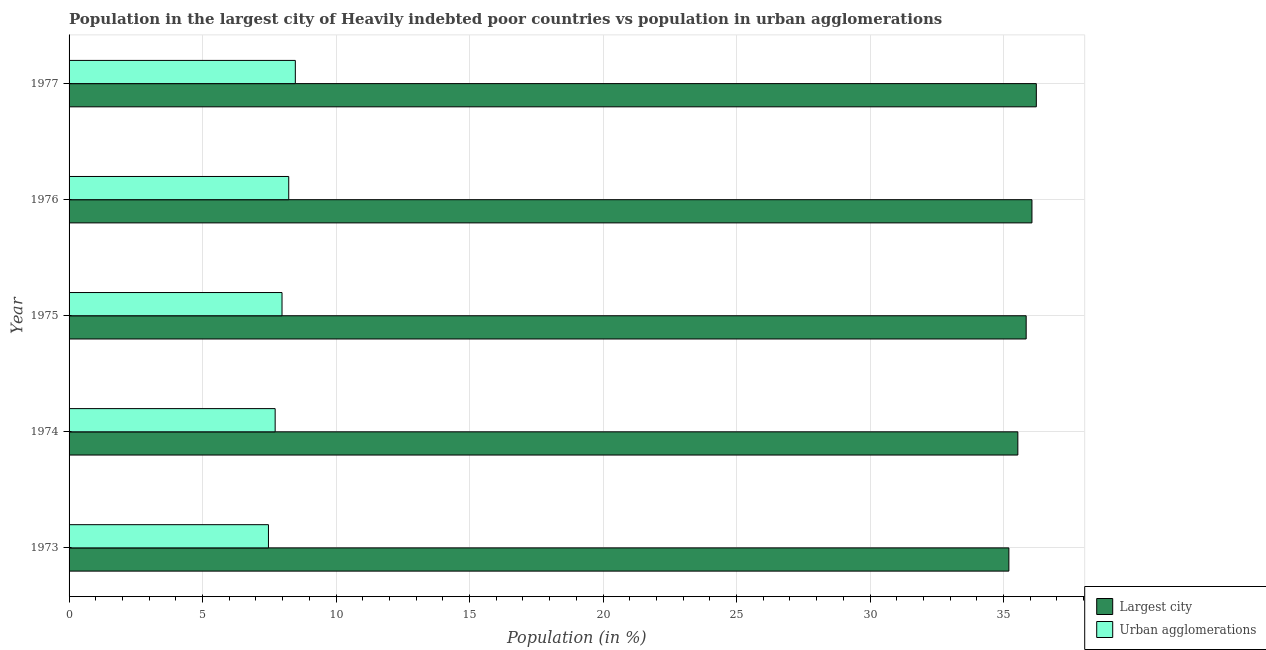How many groups of bars are there?
Your answer should be compact. 5. Are the number of bars per tick equal to the number of legend labels?
Your response must be concise. Yes. How many bars are there on the 3rd tick from the top?
Your answer should be compact. 2. In how many cases, is the number of bars for a given year not equal to the number of legend labels?
Make the answer very short. 0. What is the population in urban agglomerations in 1974?
Give a very brief answer. 7.72. Across all years, what is the maximum population in the largest city?
Offer a terse response. 36.23. Across all years, what is the minimum population in the largest city?
Provide a short and direct response. 35.2. In which year was the population in urban agglomerations maximum?
Make the answer very short. 1977. In which year was the population in urban agglomerations minimum?
Keep it short and to the point. 1973. What is the total population in urban agglomerations in the graph?
Your answer should be very brief. 39.87. What is the difference between the population in the largest city in 1975 and that in 1977?
Your answer should be very brief. -0.38. What is the difference between the population in the largest city in 1976 and the population in urban agglomerations in 1974?
Your response must be concise. 28.35. What is the average population in urban agglomerations per year?
Provide a short and direct response. 7.97. In the year 1975, what is the difference between the population in urban agglomerations and population in the largest city?
Give a very brief answer. -27.87. In how many years, is the population in the largest city greater than 14 %?
Make the answer very short. 5. What is the difference between the highest and the second highest population in the largest city?
Provide a short and direct response. 0.16. What is the difference between the highest and the lowest population in the largest city?
Offer a terse response. 1.03. In how many years, is the population in urban agglomerations greater than the average population in urban agglomerations taken over all years?
Offer a terse response. 3. Is the sum of the population in the largest city in 1976 and 1977 greater than the maximum population in urban agglomerations across all years?
Keep it short and to the point. Yes. What does the 1st bar from the top in 1974 represents?
Offer a very short reply. Urban agglomerations. What does the 1st bar from the bottom in 1976 represents?
Provide a succinct answer. Largest city. Are all the bars in the graph horizontal?
Make the answer very short. Yes. How many years are there in the graph?
Give a very brief answer. 5. Are the values on the major ticks of X-axis written in scientific E-notation?
Provide a succinct answer. No. Where does the legend appear in the graph?
Offer a terse response. Bottom right. How many legend labels are there?
Your response must be concise. 2. How are the legend labels stacked?
Offer a terse response. Vertical. What is the title of the graph?
Your answer should be very brief. Population in the largest city of Heavily indebted poor countries vs population in urban agglomerations. Does "Electricity and heat production" appear as one of the legend labels in the graph?
Make the answer very short. No. What is the Population (in %) of Largest city in 1973?
Provide a short and direct response. 35.2. What is the Population (in %) in Urban agglomerations in 1973?
Provide a short and direct response. 7.47. What is the Population (in %) in Largest city in 1974?
Offer a terse response. 35.54. What is the Population (in %) of Urban agglomerations in 1974?
Your response must be concise. 7.72. What is the Population (in %) in Largest city in 1975?
Provide a short and direct response. 35.85. What is the Population (in %) of Urban agglomerations in 1975?
Keep it short and to the point. 7.98. What is the Population (in %) in Largest city in 1976?
Make the answer very short. 36.07. What is the Population (in %) of Urban agglomerations in 1976?
Make the answer very short. 8.23. What is the Population (in %) of Largest city in 1977?
Give a very brief answer. 36.23. What is the Population (in %) of Urban agglomerations in 1977?
Your answer should be very brief. 8.47. Across all years, what is the maximum Population (in %) of Largest city?
Ensure brevity in your answer.  36.23. Across all years, what is the maximum Population (in %) of Urban agglomerations?
Keep it short and to the point. 8.47. Across all years, what is the minimum Population (in %) of Largest city?
Your response must be concise. 35.2. Across all years, what is the minimum Population (in %) of Urban agglomerations?
Give a very brief answer. 7.47. What is the total Population (in %) of Largest city in the graph?
Your answer should be very brief. 178.88. What is the total Population (in %) of Urban agglomerations in the graph?
Give a very brief answer. 39.87. What is the difference between the Population (in %) in Largest city in 1973 and that in 1974?
Give a very brief answer. -0.34. What is the difference between the Population (in %) in Urban agglomerations in 1973 and that in 1974?
Give a very brief answer. -0.25. What is the difference between the Population (in %) in Largest city in 1973 and that in 1975?
Ensure brevity in your answer.  -0.65. What is the difference between the Population (in %) in Urban agglomerations in 1973 and that in 1975?
Your answer should be compact. -0.51. What is the difference between the Population (in %) in Largest city in 1973 and that in 1976?
Ensure brevity in your answer.  -0.86. What is the difference between the Population (in %) in Urban agglomerations in 1973 and that in 1976?
Provide a succinct answer. -0.76. What is the difference between the Population (in %) of Largest city in 1973 and that in 1977?
Your answer should be very brief. -1.03. What is the difference between the Population (in %) in Urban agglomerations in 1973 and that in 1977?
Your answer should be compact. -1.01. What is the difference between the Population (in %) of Largest city in 1974 and that in 1975?
Give a very brief answer. -0.31. What is the difference between the Population (in %) in Urban agglomerations in 1974 and that in 1975?
Ensure brevity in your answer.  -0.26. What is the difference between the Population (in %) of Largest city in 1974 and that in 1976?
Your answer should be compact. -0.53. What is the difference between the Population (in %) of Urban agglomerations in 1974 and that in 1976?
Make the answer very short. -0.51. What is the difference between the Population (in %) of Largest city in 1974 and that in 1977?
Offer a terse response. -0.69. What is the difference between the Population (in %) of Urban agglomerations in 1974 and that in 1977?
Make the answer very short. -0.76. What is the difference between the Population (in %) of Largest city in 1975 and that in 1976?
Provide a short and direct response. -0.22. What is the difference between the Population (in %) in Urban agglomerations in 1975 and that in 1976?
Provide a succinct answer. -0.25. What is the difference between the Population (in %) in Largest city in 1975 and that in 1977?
Your answer should be very brief. -0.38. What is the difference between the Population (in %) in Urban agglomerations in 1975 and that in 1977?
Your answer should be compact. -0.5. What is the difference between the Population (in %) in Largest city in 1976 and that in 1977?
Your answer should be compact. -0.16. What is the difference between the Population (in %) of Urban agglomerations in 1976 and that in 1977?
Offer a very short reply. -0.25. What is the difference between the Population (in %) of Largest city in 1973 and the Population (in %) of Urban agglomerations in 1974?
Your response must be concise. 27.48. What is the difference between the Population (in %) of Largest city in 1973 and the Population (in %) of Urban agglomerations in 1975?
Provide a succinct answer. 27.23. What is the difference between the Population (in %) in Largest city in 1973 and the Population (in %) in Urban agglomerations in 1976?
Provide a short and direct response. 26.97. What is the difference between the Population (in %) of Largest city in 1973 and the Population (in %) of Urban agglomerations in 1977?
Offer a terse response. 26.73. What is the difference between the Population (in %) in Largest city in 1974 and the Population (in %) in Urban agglomerations in 1975?
Ensure brevity in your answer.  27.56. What is the difference between the Population (in %) in Largest city in 1974 and the Population (in %) in Urban agglomerations in 1976?
Make the answer very short. 27.31. What is the difference between the Population (in %) in Largest city in 1974 and the Population (in %) in Urban agglomerations in 1977?
Offer a terse response. 27.06. What is the difference between the Population (in %) in Largest city in 1975 and the Population (in %) in Urban agglomerations in 1976?
Your response must be concise. 27.62. What is the difference between the Population (in %) of Largest city in 1975 and the Population (in %) of Urban agglomerations in 1977?
Ensure brevity in your answer.  27.37. What is the difference between the Population (in %) of Largest city in 1976 and the Population (in %) of Urban agglomerations in 1977?
Give a very brief answer. 27.59. What is the average Population (in %) of Largest city per year?
Ensure brevity in your answer.  35.78. What is the average Population (in %) of Urban agglomerations per year?
Your answer should be very brief. 7.97. In the year 1973, what is the difference between the Population (in %) in Largest city and Population (in %) in Urban agglomerations?
Offer a very short reply. 27.73. In the year 1974, what is the difference between the Population (in %) in Largest city and Population (in %) in Urban agglomerations?
Offer a terse response. 27.82. In the year 1975, what is the difference between the Population (in %) of Largest city and Population (in %) of Urban agglomerations?
Offer a terse response. 27.87. In the year 1976, what is the difference between the Population (in %) in Largest city and Population (in %) in Urban agglomerations?
Offer a terse response. 27.84. In the year 1977, what is the difference between the Population (in %) in Largest city and Population (in %) in Urban agglomerations?
Your response must be concise. 27.76. What is the ratio of the Population (in %) of Largest city in 1973 to that in 1974?
Keep it short and to the point. 0.99. What is the ratio of the Population (in %) in Urban agglomerations in 1973 to that in 1974?
Your answer should be compact. 0.97. What is the ratio of the Population (in %) in Largest city in 1973 to that in 1975?
Your response must be concise. 0.98. What is the ratio of the Population (in %) in Urban agglomerations in 1973 to that in 1975?
Your answer should be compact. 0.94. What is the ratio of the Population (in %) of Largest city in 1973 to that in 1976?
Provide a succinct answer. 0.98. What is the ratio of the Population (in %) in Urban agglomerations in 1973 to that in 1976?
Keep it short and to the point. 0.91. What is the ratio of the Population (in %) of Largest city in 1973 to that in 1977?
Your response must be concise. 0.97. What is the ratio of the Population (in %) in Urban agglomerations in 1973 to that in 1977?
Your answer should be very brief. 0.88. What is the ratio of the Population (in %) of Largest city in 1974 to that in 1975?
Provide a short and direct response. 0.99. What is the ratio of the Population (in %) in Urban agglomerations in 1974 to that in 1975?
Keep it short and to the point. 0.97. What is the ratio of the Population (in %) of Largest city in 1974 to that in 1976?
Give a very brief answer. 0.99. What is the ratio of the Population (in %) of Urban agglomerations in 1974 to that in 1976?
Your answer should be compact. 0.94. What is the ratio of the Population (in %) of Largest city in 1974 to that in 1977?
Ensure brevity in your answer.  0.98. What is the ratio of the Population (in %) of Urban agglomerations in 1974 to that in 1977?
Your response must be concise. 0.91. What is the ratio of the Population (in %) of Urban agglomerations in 1975 to that in 1976?
Offer a terse response. 0.97. What is the ratio of the Population (in %) in Urban agglomerations in 1975 to that in 1977?
Your answer should be compact. 0.94. What is the ratio of the Population (in %) in Largest city in 1976 to that in 1977?
Your answer should be very brief. 1. What is the ratio of the Population (in %) of Urban agglomerations in 1976 to that in 1977?
Provide a succinct answer. 0.97. What is the difference between the highest and the second highest Population (in %) in Largest city?
Provide a short and direct response. 0.16. What is the difference between the highest and the second highest Population (in %) of Urban agglomerations?
Offer a very short reply. 0.25. What is the difference between the highest and the lowest Population (in %) in Largest city?
Make the answer very short. 1.03. 